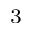<formula> <loc_0><loc_0><loc_500><loc_500>_ { 3 }</formula> 